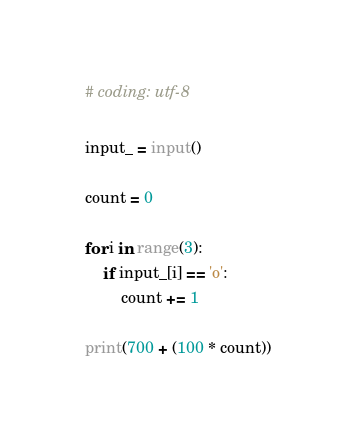Convert code to text. <code><loc_0><loc_0><loc_500><loc_500><_Python_># coding: utf-8

input_ = input()

count = 0

for i in range(3):
    if input_[i] == 'o':
        count += 1

print(700 + (100 * count))
</code> 